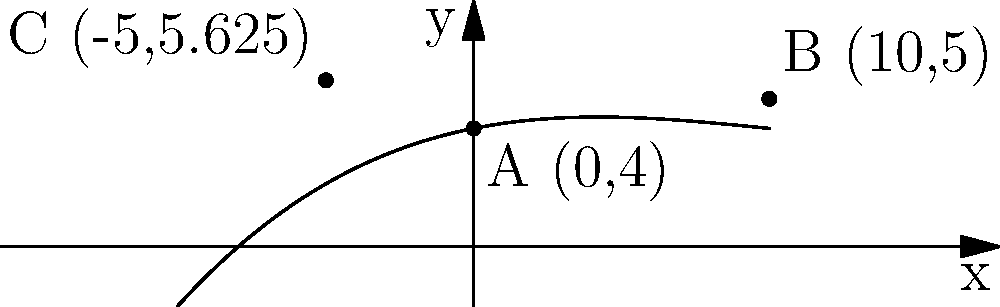A skateboard enthusiast wants to design a custom deck shape using polynomial interpolation. The shape is represented by a cubic function $f(x) = ax^3 + bx^2 + cx + d$ that passes through three points: A(0,4), B(10,5), and C(-5,5.625). What is the value of the coefficient $a$ in the cubic function? To find the coefficient $a$, we'll use the given points to create a system of equations and solve it:

1) First, let's write out the equations for each point:
   A(0,4): $d = 4$
   B(10,5): $1000a + 100b + 10c + 4 = 5$
   C(-5,5.625): $-125a + 25b - 5c + 4 = 5.625$

2) Substitute $d = 4$ into the other equations:
   $1000a + 100b + 10c = 1$
   $-125a + 25b - 5c = 1.625$

3) To simplify, let's divide the first equation by 10:
   $100a + 10b + c = 0.1$
   $-125a + 25b - 5c = 1.625$

4) Multiply the first equation by 5 and add it to the second:
   $500a + 50b + 5c = 0.5$
   $-125a + 25b - 5c = 1.625$
   $375a + 75b = 2.125$

5) Divide this equation by 75:
   $5a + b = \frac{2.125}{75} = \frac{17}{600}$

6) Substitute this expression for $b$ into the equation from step 3:
   $100a + 10(\frac{17}{600} - 5a) + c = 0.1$
   $100a + \frac{17}{60} - 50a + c = 0.1$
   $50a + c = 0.1 - \frac{17}{60}$

7) Now we have:
   $50a + c = 0.1 - \frac{17}{60} = -\frac{1}{600}$
   $-125a + 25b - 5c = 1.625$

8) Multiply the first equation by 5 and add to the second:
   $250a + 5c = -\frac{1}{120}$
   $-125a + 25b - 5c = 1.625$
   $125a + 25b = \frac{1.625 \cdot 120 - 1}{120} = \frac{194}{120}$

9) Divide by 125:
   $a + \frac{b}{5} = \frac{194}{15000}$

10) Substitute this into the equation from step 5:
    $5(\frac{194}{15000} - \frac{b}{5}) + b = \frac{17}{600}$
    $\frac{194}{3000} - b + b = \frac{17}{600}$
    $\frac{194}{3000} = \frac{17}{600}$

11) Solve for $a$:
    $a = \frac{194}{15000} - \frac{b}{5} = \frac{194}{15000} - \frac{1}{5}(\frac{17}{600} - \frac{194}{3000}) = 0.001$

Therefore, the coefficient $a$ in the cubic function is 0.001.
Answer: $a = 0.001$ 